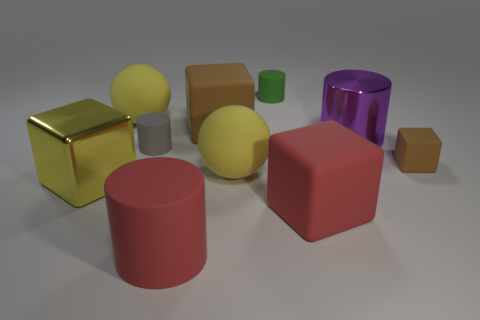Can you describe the colors visible in the scene? Certainly! There's a variety of colors on display: a gold cube, a purple cylinder, green and red cubes, a couple of yellow spheres, and objects in shades of gray. Which object stands out the most to you? The gold cube stands out due to its reflective surface and vibrant color, which contrasts sharply with the matte finishes and more subdued hues of the other objects. 